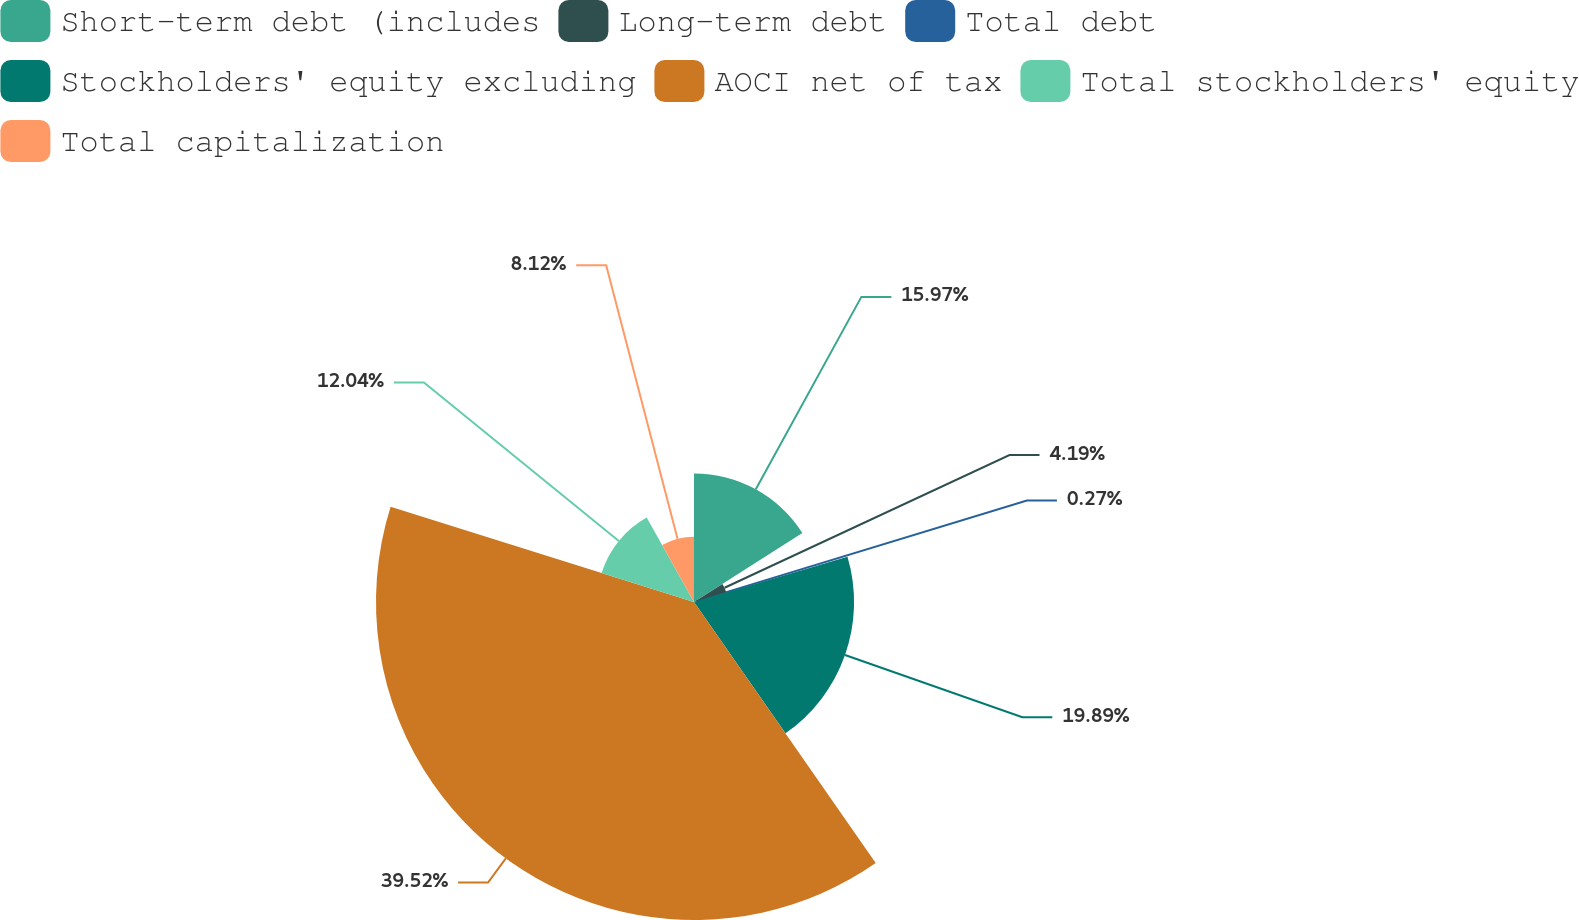Convert chart to OTSL. <chart><loc_0><loc_0><loc_500><loc_500><pie_chart><fcel>Short-term debt (includes<fcel>Long-term debt<fcel>Total debt<fcel>Stockholders' equity excluding<fcel>AOCI net of tax<fcel>Total stockholders' equity<fcel>Total capitalization<nl><fcel>15.97%<fcel>4.19%<fcel>0.27%<fcel>19.89%<fcel>39.52%<fcel>12.04%<fcel>8.12%<nl></chart> 